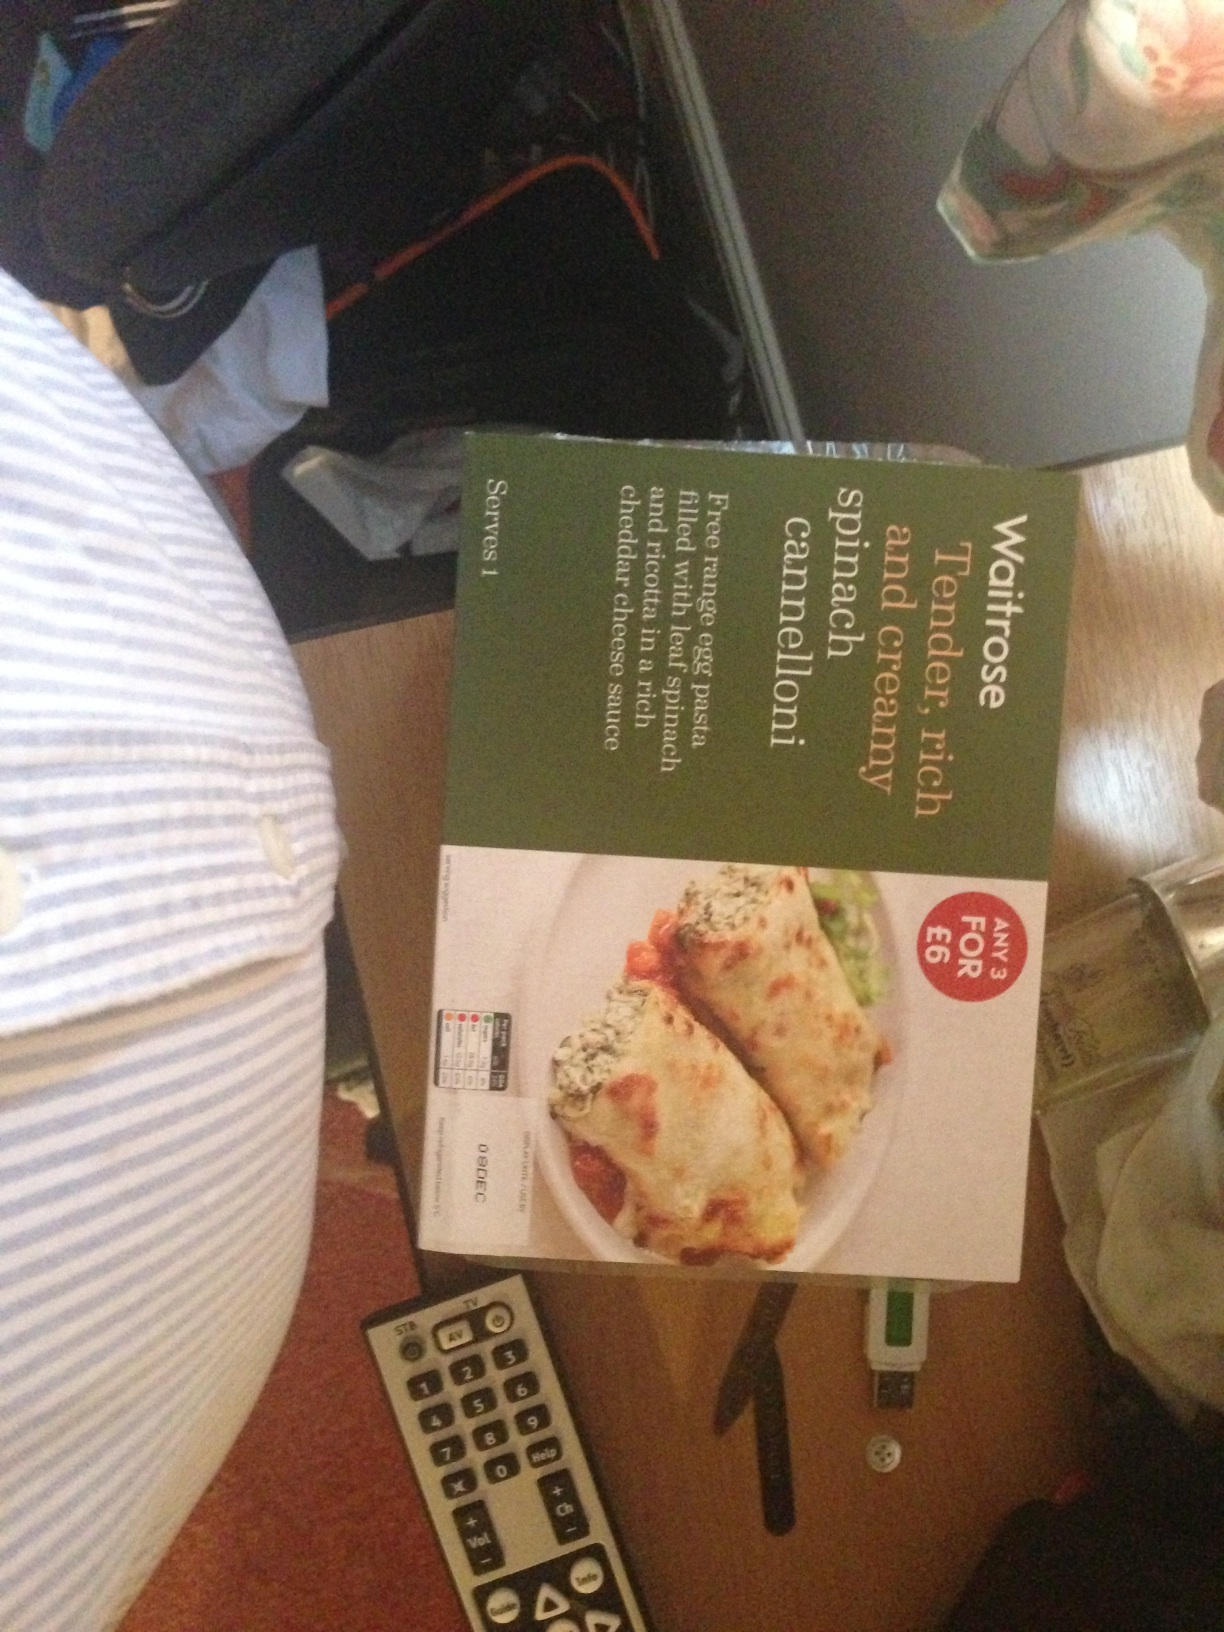How would you describe the nutritional value of this meal? While I can't provide specific nutritional information without seeing the label, a typical spinach cannelloni ready meal is often rich in calcium from the cheese and may have a decent amount of iron from the spinach. However, it could also be high in calories and saturated fat due to the cheese and creamy sauce. It's advisable to check the packaging for detailed nutrition facts. 